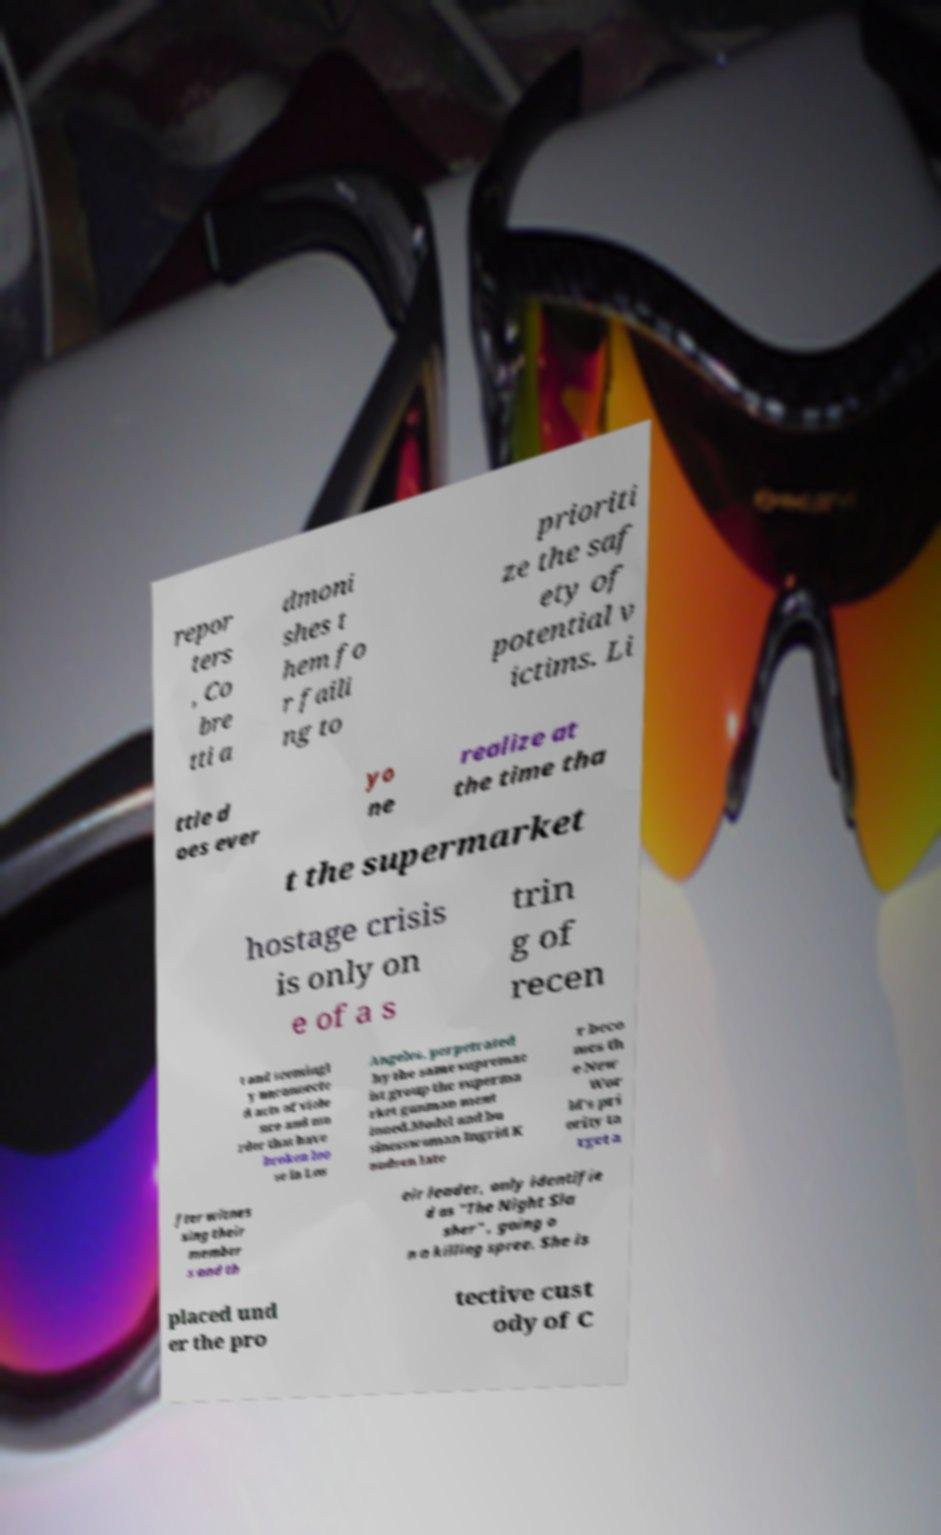What messages or text are displayed in this image? I need them in a readable, typed format. repor ters , Co bre tti a dmoni shes t hem fo r faili ng to prioriti ze the saf ety of potential v ictims. Li ttle d oes ever yo ne realize at the time tha t the supermarket hostage crisis is only on e of a s trin g of recen t and seemingl y unconnecte d acts of viole nce and mu rder that have broken loo se in Los Angeles, perpetrated by the same supremac ist group the superma rket gunman ment ioned.Model and bu sinesswoman Ingrid K nudsen late r beco mes th e New Wor ld's pri ority ta rget a fter witnes sing their member s and th eir leader, only identifie d as "The Night Sla sher" , going o n a killing spree. She is placed und er the pro tective cust ody of C 